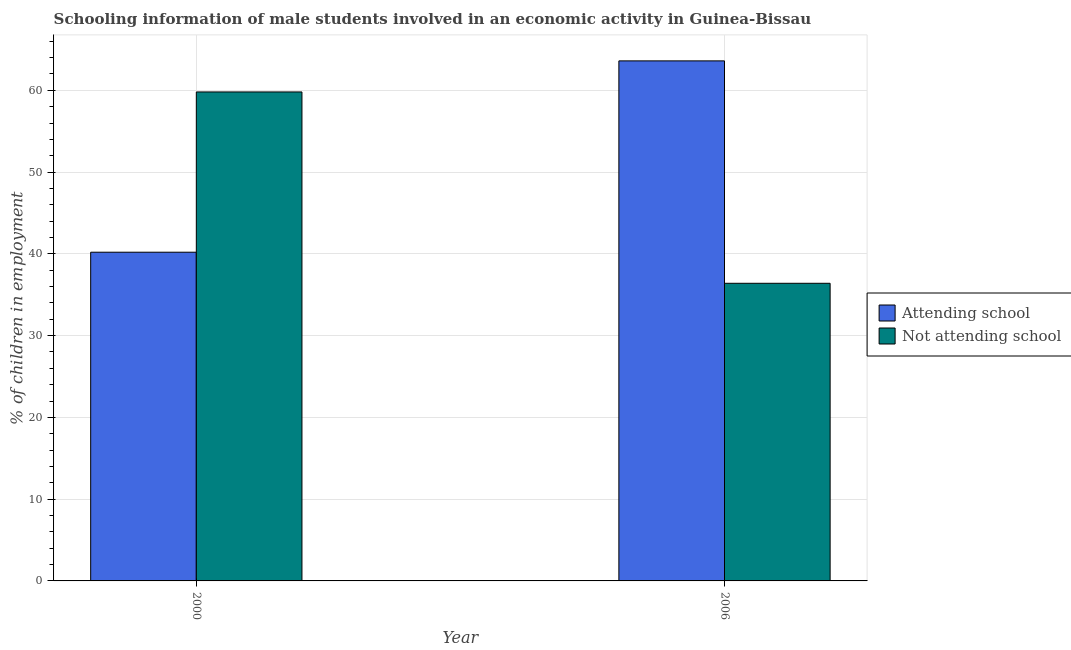Are the number of bars per tick equal to the number of legend labels?
Offer a very short reply. Yes. How many bars are there on the 1st tick from the left?
Provide a succinct answer. 2. How many bars are there on the 2nd tick from the right?
Provide a succinct answer. 2. What is the label of the 1st group of bars from the left?
Offer a terse response. 2000. What is the percentage of employed males who are attending school in 2000?
Provide a succinct answer. 40.2. Across all years, what is the maximum percentage of employed males who are attending school?
Your answer should be compact. 63.6. Across all years, what is the minimum percentage of employed males who are not attending school?
Your answer should be compact. 36.4. In which year was the percentage of employed males who are not attending school maximum?
Offer a very short reply. 2000. What is the total percentage of employed males who are not attending school in the graph?
Offer a terse response. 96.2. What is the difference between the percentage of employed males who are attending school in 2000 and that in 2006?
Your response must be concise. -23.4. What is the difference between the percentage of employed males who are attending school in 2006 and the percentage of employed males who are not attending school in 2000?
Your answer should be very brief. 23.4. What is the average percentage of employed males who are not attending school per year?
Offer a terse response. 48.1. In how many years, is the percentage of employed males who are not attending school greater than 12 %?
Offer a very short reply. 2. What is the ratio of the percentage of employed males who are attending school in 2000 to that in 2006?
Provide a short and direct response. 0.63. In how many years, is the percentage of employed males who are attending school greater than the average percentage of employed males who are attending school taken over all years?
Make the answer very short. 1. What does the 1st bar from the left in 2006 represents?
Give a very brief answer. Attending school. What does the 1st bar from the right in 2006 represents?
Provide a succinct answer. Not attending school. Are all the bars in the graph horizontal?
Provide a succinct answer. No. What is the difference between two consecutive major ticks on the Y-axis?
Ensure brevity in your answer.  10. How are the legend labels stacked?
Your answer should be compact. Vertical. What is the title of the graph?
Make the answer very short. Schooling information of male students involved in an economic activity in Guinea-Bissau. Does "Age 65(male)" appear as one of the legend labels in the graph?
Make the answer very short. No. What is the label or title of the X-axis?
Ensure brevity in your answer.  Year. What is the label or title of the Y-axis?
Your answer should be compact. % of children in employment. What is the % of children in employment of Attending school in 2000?
Keep it short and to the point. 40.2. What is the % of children in employment in Not attending school in 2000?
Ensure brevity in your answer.  59.8. What is the % of children in employment in Attending school in 2006?
Your response must be concise. 63.6. What is the % of children in employment of Not attending school in 2006?
Your answer should be compact. 36.4. Across all years, what is the maximum % of children in employment of Attending school?
Offer a very short reply. 63.6. Across all years, what is the maximum % of children in employment of Not attending school?
Provide a short and direct response. 59.8. Across all years, what is the minimum % of children in employment of Attending school?
Your answer should be compact. 40.2. Across all years, what is the minimum % of children in employment of Not attending school?
Give a very brief answer. 36.4. What is the total % of children in employment of Attending school in the graph?
Your response must be concise. 103.8. What is the total % of children in employment of Not attending school in the graph?
Your response must be concise. 96.2. What is the difference between the % of children in employment in Attending school in 2000 and that in 2006?
Make the answer very short. -23.4. What is the difference between the % of children in employment of Not attending school in 2000 and that in 2006?
Your answer should be very brief. 23.4. What is the average % of children in employment of Attending school per year?
Make the answer very short. 51.9. What is the average % of children in employment in Not attending school per year?
Provide a succinct answer. 48.1. In the year 2000, what is the difference between the % of children in employment of Attending school and % of children in employment of Not attending school?
Keep it short and to the point. -19.6. In the year 2006, what is the difference between the % of children in employment in Attending school and % of children in employment in Not attending school?
Provide a short and direct response. 27.2. What is the ratio of the % of children in employment of Attending school in 2000 to that in 2006?
Your response must be concise. 0.63. What is the ratio of the % of children in employment of Not attending school in 2000 to that in 2006?
Provide a short and direct response. 1.64. What is the difference between the highest and the second highest % of children in employment in Attending school?
Your answer should be compact. 23.4. What is the difference between the highest and the second highest % of children in employment of Not attending school?
Keep it short and to the point. 23.4. What is the difference between the highest and the lowest % of children in employment of Attending school?
Offer a very short reply. 23.4. What is the difference between the highest and the lowest % of children in employment in Not attending school?
Your answer should be very brief. 23.4. 